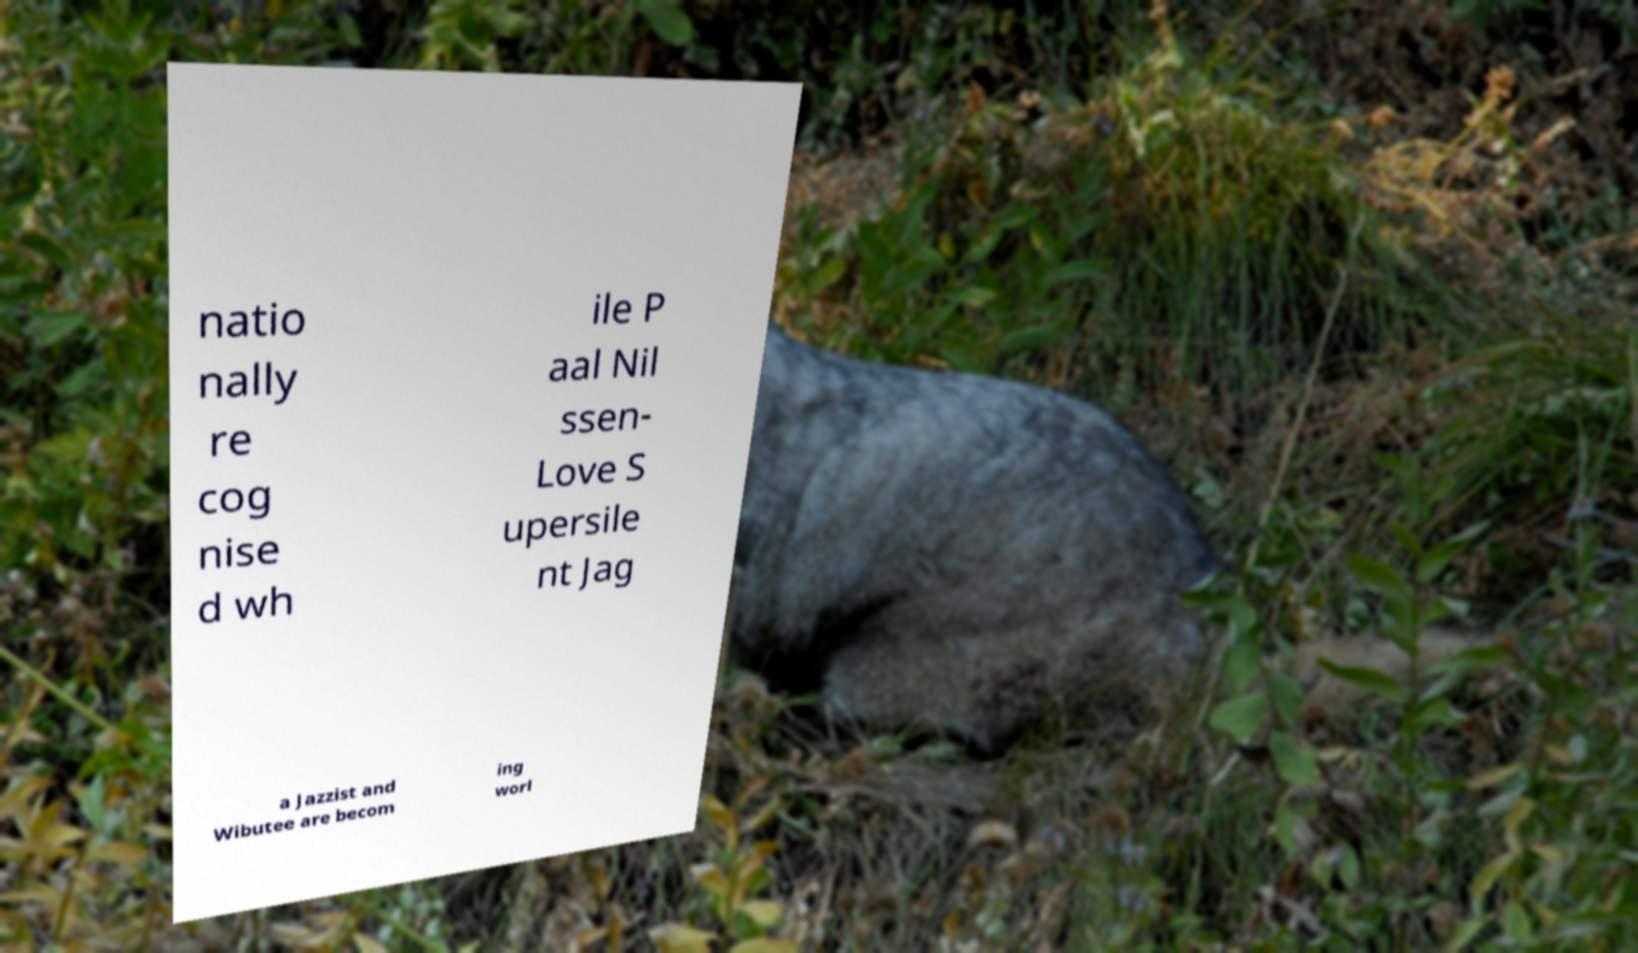I need the written content from this picture converted into text. Can you do that? natio nally re cog nise d wh ile P aal Nil ssen- Love S upersile nt Jag a Jazzist and Wibutee are becom ing worl 